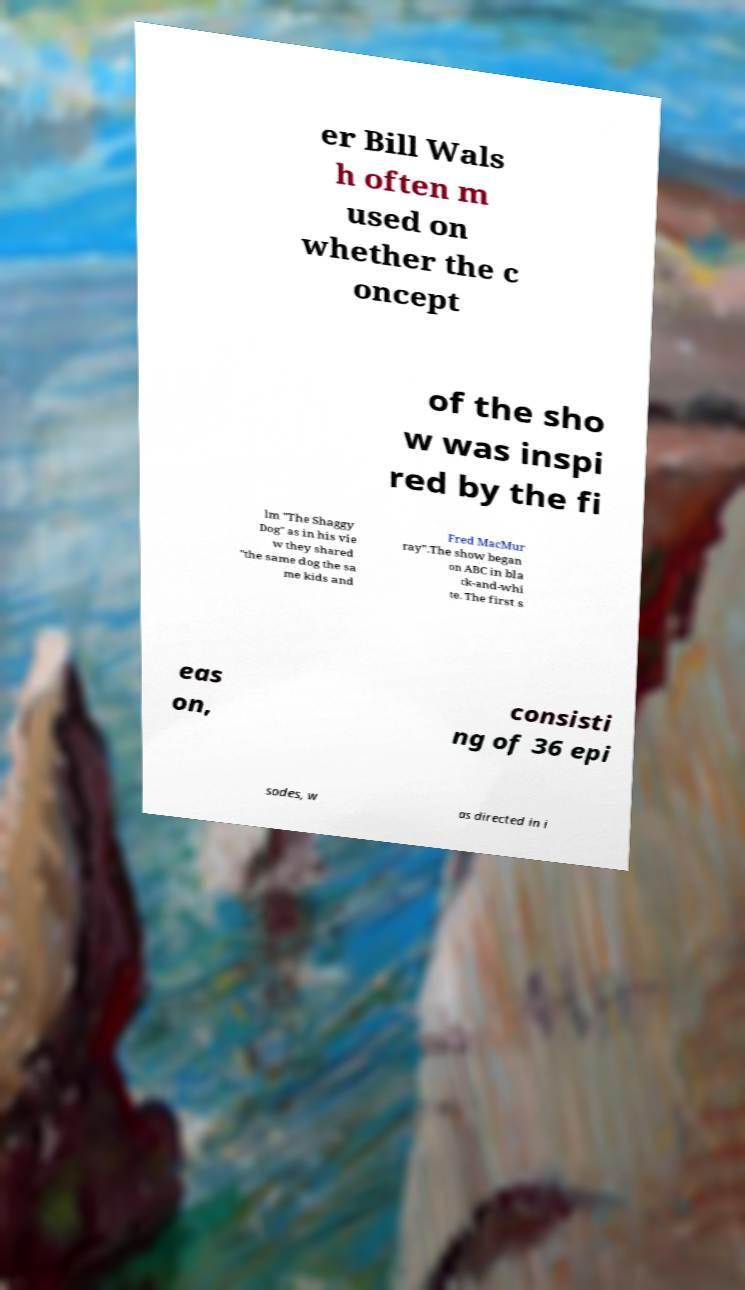Could you assist in decoding the text presented in this image and type it out clearly? er Bill Wals h often m used on whether the c oncept of the sho w was inspi red by the fi lm "The Shaggy Dog" as in his vie w they shared "the same dog the sa me kids and Fred MacMur ray".The show began on ABC in bla ck-and-whi te. The first s eas on, consisti ng of 36 epi sodes, w as directed in i 